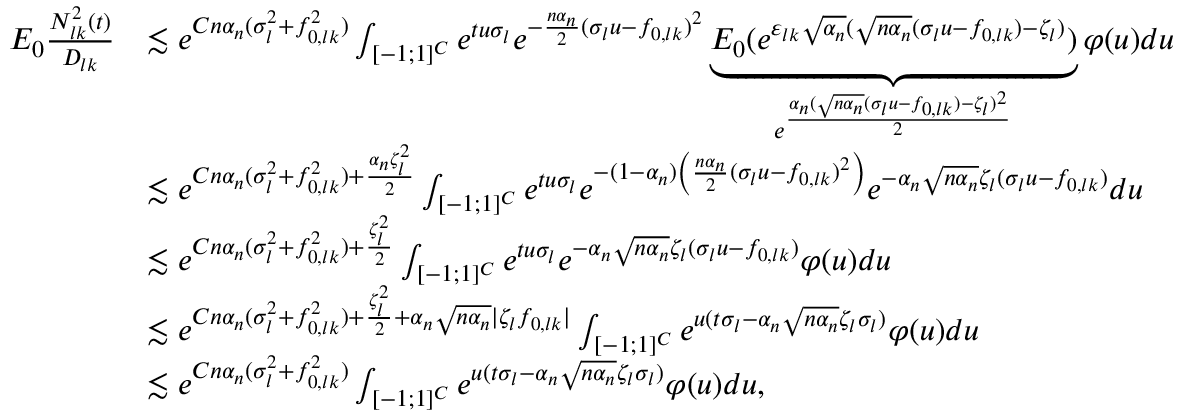<formula> <loc_0><loc_0><loc_500><loc_500>\begin{array} { r l } { E _ { 0 } \frac { N _ { l k } ^ { 2 } ( t ) } { D _ { l k } } } & { \lesssim e ^ { C n \alpha _ { n } ( \sigma _ { l } ^ { 2 } + f _ { 0 , l k } ^ { 2 } ) } \int _ { [ - 1 ; 1 ] ^ { C } } e ^ { t u \sigma _ { l } } e ^ { - \frac { n \alpha _ { n } } { 2 } ( \sigma _ { l } u - f _ { 0 , l k } ) ^ { 2 } } \underbrace { E _ { 0 } ( e ^ { \varepsilon _ { l k } \sqrt { \alpha _ { n } } ( \sqrt { n \alpha _ { n } } ( \sigma _ { l } u - f _ { 0 , l k } ) - \zeta _ { l } ) } ) } _ { e ^ { \frac { \alpha _ { n } ( \sqrt { n \alpha _ { n } } ( \sigma _ { l } u - f _ { 0 , l k } ) - \zeta _ { l } ) ^ { 2 } } { 2 } } } \varphi ( u ) d u } \\ & { \lesssim e ^ { C n \alpha _ { n } ( \sigma _ { l } ^ { 2 } + f _ { 0 , l k } ^ { 2 } ) + \frac { \alpha _ { n } \zeta _ { l } ^ { 2 } } { 2 } } \int _ { [ - 1 ; 1 ] ^ { C } } e ^ { t u \sigma _ { l } } e ^ { - ( 1 - \alpha _ { n } ) \left ( \frac { n \alpha _ { n } } { 2 } ( \sigma _ { l } u - f _ { 0 , l k } ) ^ { 2 } \right ) } e ^ { - \alpha _ { n } \sqrt { n \alpha _ { n } } \zeta _ { l } ( \sigma _ { l } u - f _ { 0 , l k } ) } d u } \\ & { \lesssim e ^ { C n \alpha _ { n } ( \sigma _ { l } ^ { 2 } + f _ { 0 , l k } ^ { 2 } ) + \frac { \zeta _ { l } ^ { 2 } } { 2 } } \int _ { [ - 1 ; 1 ] ^ { C } } e ^ { t u \sigma _ { l } } e ^ { - \alpha _ { n } \sqrt { n \alpha _ { n } } \zeta _ { l } ( \sigma _ { l } u - f _ { 0 , l k } ) } \varphi ( u ) d u } \\ & { \lesssim e ^ { C n \alpha _ { n } ( \sigma _ { l } ^ { 2 } + f _ { 0 , l k } ^ { 2 } ) + \frac { \zeta _ { l } ^ { 2 } } { 2 } + \alpha _ { n } \sqrt { n \alpha _ { n } } | \zeta _ { l } f _ { 0 , l k } | } \int _ { [ - 1 ; 1 ] ^ { C } } e ^ { u ( t \sigma _ { l } - \alpha _ { n } \sqrt { n \alpha _ { n } } \zeta _ { l } \sigma _ { l } ) } \varphi ( u ) d u } \\ & { \lesssim e ^ { C n \alpha _ { n } ( \sigma _ { l } ^ { 2 } + f _ { 0 , l k } ^ { 2 } ) } \int _ { [ - 1 ; 1 ] ^ { C } } e ^ { u ( t \sigma _ { l } - \alpha _ { n } \sqrt { n \alpha _ { n } } \zeta _ { l } \sigma _ { l } ) } \varphi ( u ) d u , } \end{array}</formula> 